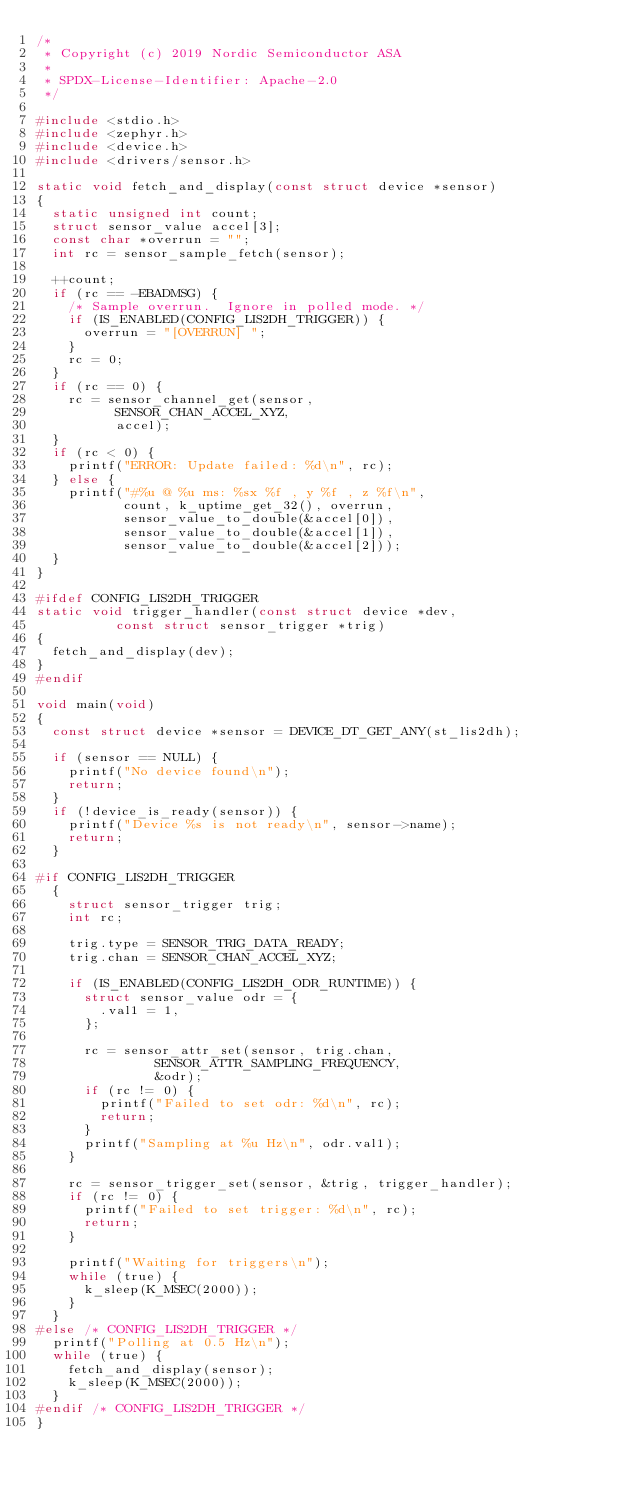<code> <loc_0><loc_0><loc_500><loc_500><_C_>/*
 * Copyright (c) 2019 Nordic Semiconductor ASA
 *
 * SPDX-License-Identifier: Apache-2.0
 */

#include <stdio.h>
#include <zephyr.h>
#include <device.h>
#include <drivers/sensor.h>

static void fetch_and_display(const struct device *sensor)
{
	static unsigned int count;
	struct sensor_value accel[3];
	const char *overrun = "";
	int rc = sensor_sample_fetch(sensor);

	++count;
	if (rc == -EBADMSG) {
		/* Sample overrun.  Ignore in polled mode. */
		if (IS_ENABLED(CONFIG_LIS2DH_TRIGGER)) {
			overrun = "[OVERRUN] ";
		}
		rc = 0;
	}
	if (rc == 0) {
		rc = sensor_channel_get(sensor,
					SENSOR_CHAN_ACCEL_XYZ,
					accel);
	}
	if (rc < 0) {
		printf("ERROR: Update failed: %d\n", rc);
	} else {
		printf("#%u @ %u ms: %sx %f , y %f , z %f\n",
		       count, k_uptime_get_32(), overrun,
		       sensor_value_to_double(&accel[0]),
		       sensor_value_to_double(&accel[1]),
		       sensor_value_to_double(&accel[2]));
	}
}

#ifdef CONFIG_LIS2DH_TRIGGER
static void trigger_handler(const struct device *dev,
			    const struct sensor_trigger *trig)
{
	fetch_and_display(dev);
}
#endif

void main(void)
{
	const struct device *sensor = DEVICE_DT_GET_ANY(st_lis2dh);

	if (sensor == NULL) {
		printf("No device found\n");
		return;
	}
	if (!device_is_ready(sensor)) {
		printf("Device %s is not ready\n", sensor->name);
		return;
	}

#if CONFIG_LIS2DH_TRIGGER
	{
		struct sensor_trigger trig;
		int rc;

		trig.type = SENSOR_TRIG_DATA_READY;
		trig.chan = SENSOR_CHAN_ACCEL_XYZ;

		if (IS_ENABLED(CONFIG_LIS2DH_ODR_RUNTIME)) {
			struct sensor_value odr = {
				.val1 = 1,
			};

			rc = sensor_attr_set(sensor, trig.chan,
					     SENSOR_ATTR_SAMPLING_FREQUENCY,
					     &odr);
			if (rc != 0) {
				printf("Failed to set odr: %d\n", rc);
				return;
			}
			printf("Sampling at %u Hz\n", odr.val1);
		}

		rc = sensor_trigger_set(sensor, &trig, trigger_handler);
		if (rc != 0) {
			printf("Failed to set trigger: %d\n", rc);
			return;
		}

		printf("Waiting for triggers\n");
		while (true) {
			k_sleep(K_MSEC(2000));
		}
	}
#else /* CONFIG_LIS2DH_TRIGGER */
	printf("Polling at 0.5 Hz\n");
	while (true) {
		fetch_and_display(sensor);
		k_sleep(K_MSEC(2000));
	}
#endif /* CONFIG_LIS2DH_TRIGGER */
}
</code> 